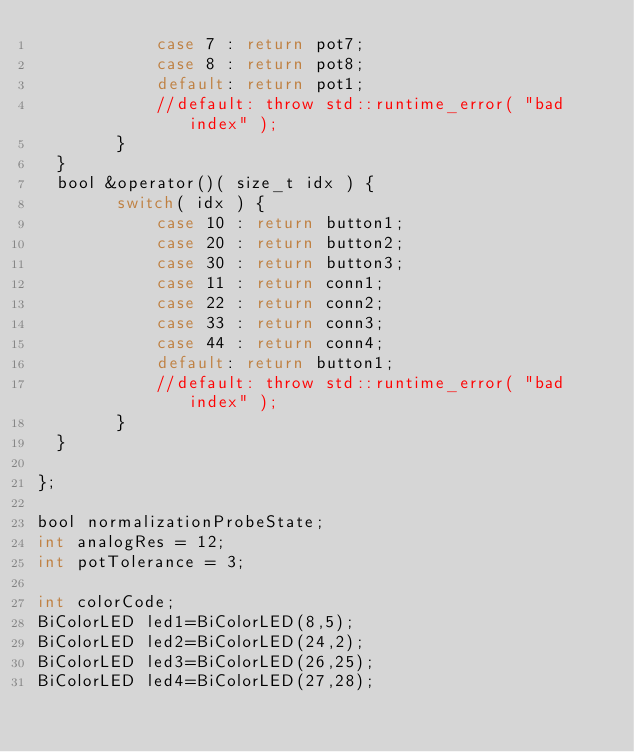<code> <loc_0><loc_0><loc_500><loc_500><_C_>            case 7 : return pot7;
            case 8 : return pot8;
            default: return pot1;
            //default: throw std::runtime_error( "bad index" );
        }
  }
  bool &operator()( size_t idx ) {
        switch( idx ) {
            case 10 : return button1;
            case 20 : return button2;
            case 30 : return button3;
            case 11 : return conn1;
            case 22 : return conn2;
            case 33 : return conn3;
            case 44 : return conn4;
            default: return button1;
            //default: throw std::runtime_error( "bad index" );
        }
  }
    
};

bool normalizationProbeState;
int analogRes = 12;
int potTolerance = 3;

int colorCode;
BiColorLED led1=BiColorLED(8,5);
BiColorLED led2=BiColorLED(24,2);
BiColorLED led3=BiColorLED(26,25);
BiColorLED led4=BiColorLED(27,28);
</code> 